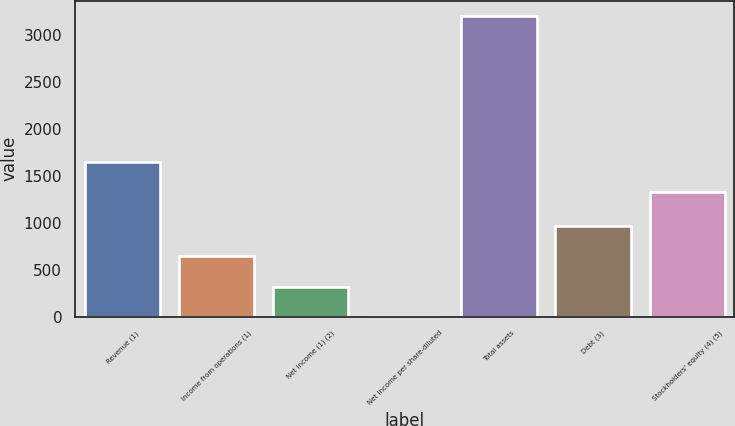<chart> <loc_0><loc_0><loc_500><loc_500><bar_chart><fcel>Revenue (1)<fcel>Income from operations (1)<fcel>Net income (1) (2)<fcel>Net income per share-diluted<fcel>Total assets<fcel>Debt (3)<fcel>Stockholders' equity (4) (5)<nl><fcel>1654.51<fcel>642.34<fcel>321.43<fcel>0.52<fcel>3209.6<fcel>963.25<fcel>1333.6<nl></chart> 